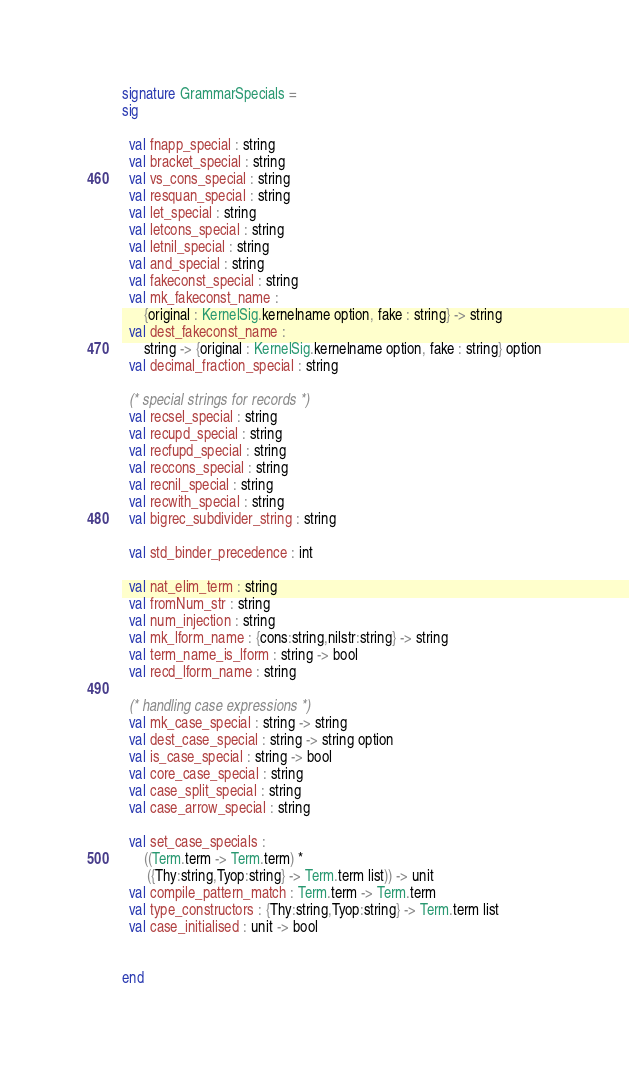<code> <loc_0><loc_0><loc_500><loc_500><_SML_>signature GrammarSpecials =
sig

  val fnapp_special : string
  val bracket_special : string
  val vs_cons_special : string
  val resquan_special : string
  val let_special : string
  val letcons_special : string
  val letnil_special : string
  val and_special : string
  val fakeconst_special : string
  val mk_fakeconst_name :
      {original : KernelSig.kernelname option, fake : string} -> string
  val dest_fakeconst_name :
      string -> {original : KernelSig.kernelname option, fake : string} option
  val decimal_fraction_special : string

  (* special strings for records *)
  val recsel_special : string
  val recupd_special : string
  val recfupd_special : string
  val reccons_special : string
  val recnil_special : string
  val recwith_special : string
  val bigrec_subdivider_string : string

  val std_binder_precedence : int

  val nat_elim_term : string
  val fromNum_str : string
  val num_injection : string
  val mk_lform_name : {cons:string,nilstr:string} -> string
  val term_name_is_lform : string -> bool
  val recd_lform_name : string

  (* handling case expressions *)
  val mk_case_special : string -> string
  val dest_case_special : string -> string option
  val is_case_special : string -> bool
  val core_case_special : string
  val case_split_special : string
  val case_arrow_special : string

  val set_case_specials :
      ((Term.term -> Term.term) *
       ({Thy:string,Tyop:string} -> Term.term list)) -> unit
  val compile_pattern_match : Term.term -> Term.term
  val type_constructors : {Thy:string,Tyop:string} -> Term.term list
  val case_initialised : unit -> bool


end
</code> 